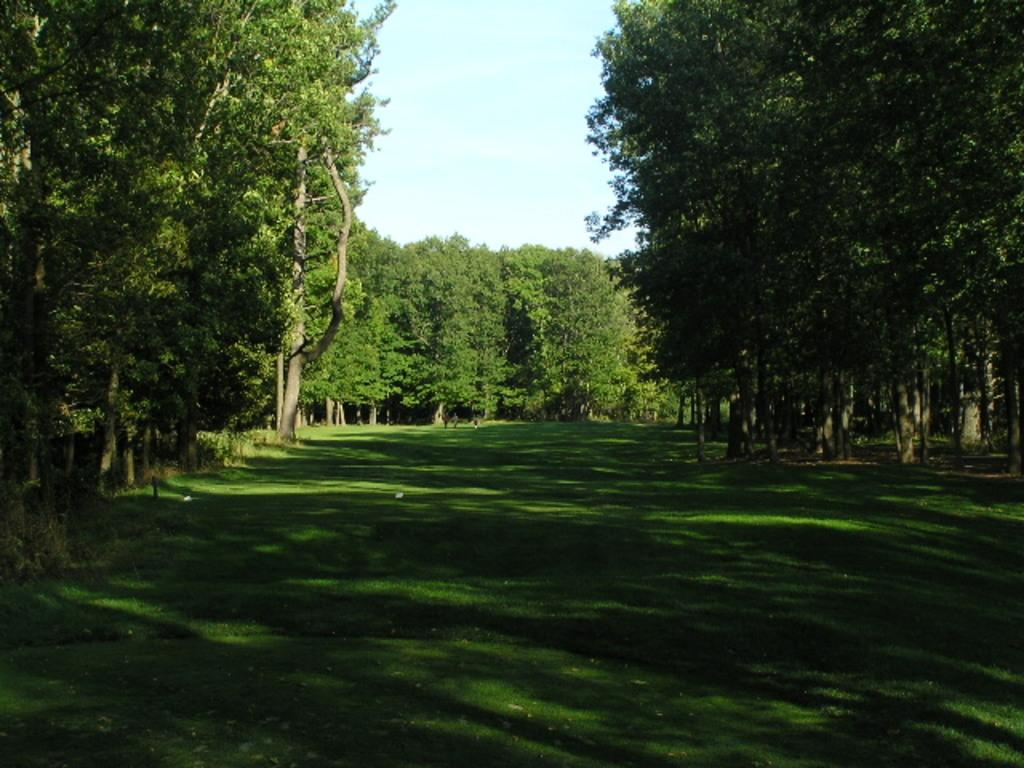What type of surface is visible in the image? There is a grass surface in the image. What can be seen on either side of the grass surface? There are trees on either side of the grass surface. What else is visible in the background of the image? There are trees and the sky visible in the background of the image. What year is depicted in the image? The image does not depict a specific year; it is a photograph of a grass surface, trees, and the sky. Can you see any trains in the image? There are no trains present in the image. 